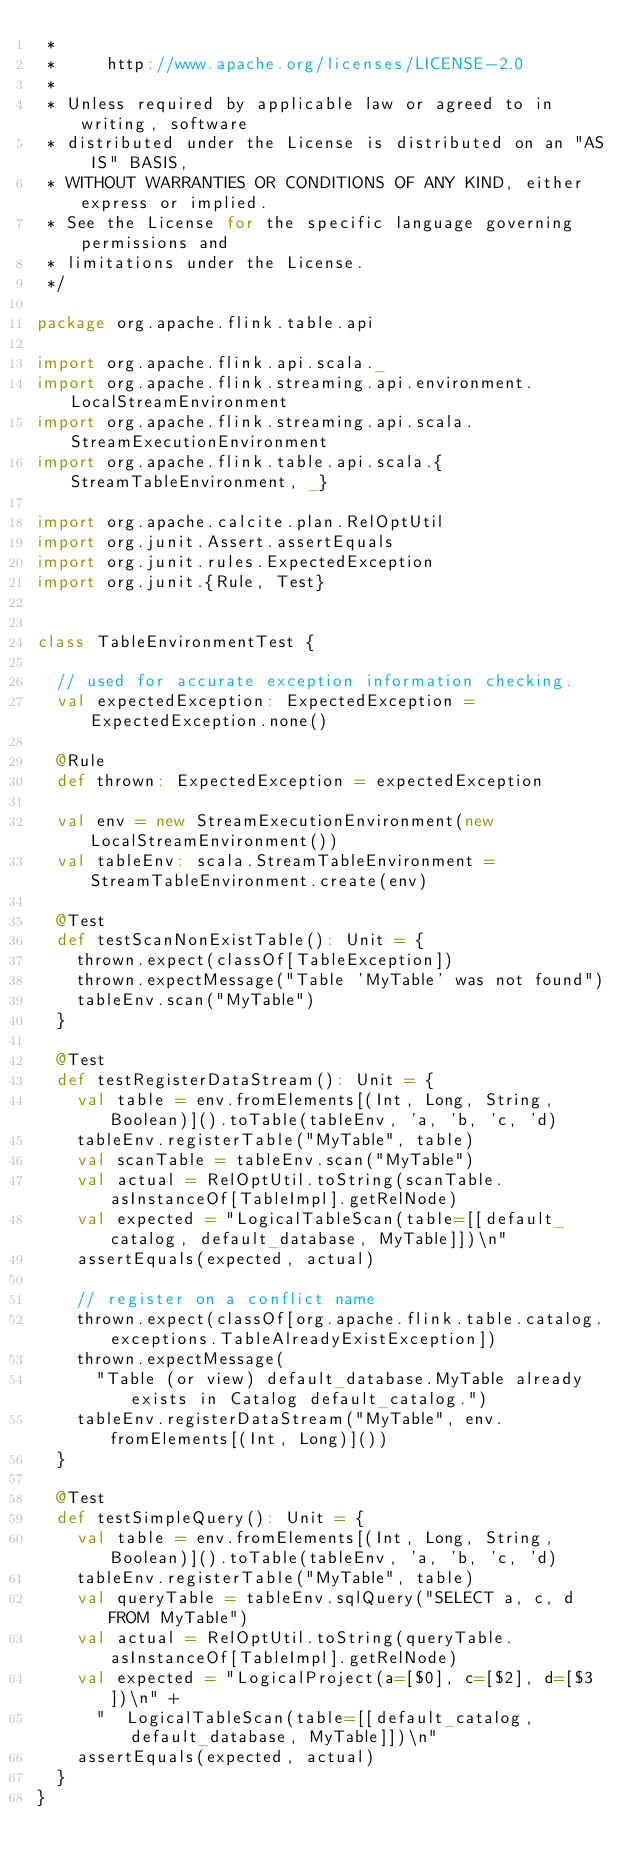<code> <loc_0><loc_0><loc_500><loc_500><_Scala_> *
 *     http://www.apache.org/licenses/LICENSE-2.0
 *
 * Unless required by applicable law or agreed to in writing, software
 * distributed under the License is distributed on an "AS IS" BASIS,
 * WITHOUT WARRANTIES OR CONDITIONS OF ANY KIND, either express or implied.
 * See the License for the specific language governing permissions and
 * limitations under the License.
 */

package org.apache.flink.table.api

import org.apache.flink.api.scala._
import org.apache.flink.streaming.api.environment.LocalStreamEnvironment
import org.apache.flink.streaming.api.scala.StreamExecutionEnvironment
import org.apache.flink.table.api.scala.{StreamTableEnvironment, _}

import org.apache.calcite.plan.RelOptUtil
import org.junit.Assert.assertEquals
import org.junit.rules.ExpectedException
import org.junit.{Rule, Test}


class TableEnvironmentTest {

  // used for accurate exception information checking.
  val expectedException: ExpectedException = ExpectedException.none()

  @Rule
  def thrown: ExpectedException = expectedException

  val env = new StreamExecutionEnvironment(new LocalStreamEnvironment())
  val tableEnv: scala.StreamTableEnvironment = StreamTableEnvironment.create(env)

  @Test
  def testScanNonExistTable(): Unit = {
    thrown.expect(classOf[TableException])
    thrown.expectMessage("Table 'MyTable' was not found")
    tableEnv.scan("MyTable")
  }

  @Test
  def testRegisterDataStream(): Unit = {
    val table = env.fromElements[(Int, Long, String, Boolean)]().toTable(tableEnv, 'a, 'b, 'c, 'd)
    tableEnv.registerTable("MyTable", table)
    val scanTable = tableEnv.scan("MyTable")
    val actual = RelOptUtil.toString(scanTable.asInstanceOf[TableImpl].getRelNode)
    val expected = "LogicalTableScan(table=[[default_catalog, default_database, MyTable]])\n"
    assertEquals(expected, actual)

    // register on a conflict name
    thrown.expect(classOf[org.apache.flink.table.catalog.exceptions.TableAlreadyExistException])
    thrown.expectMessage(
      "Table (or view) default_database.MyTable already exists in Catalog default_catalog.")
    tableEnv.registerDataStream("MyTable", env.fromElements[(Int, Long)]())
  }

  @Test
  def testSimpleQuery(): Unit = {
    val table = env.fromElements[(Int, Long, String, Boolean)]().toTable(tableEnv, 'a, 'b, 'c, 'd)
    tableEnv.registerTable("MyTable", table)
    val queryTable = tableEnv.sqlQuery("SELECT a, c, d FROM MyTable")
    val actual = RelOptUtil.toString(queryTable.asInstanceOf[TableImpl].getRelNode)
    val expected = "LogicalProject(a=[$0], c=[$2], d=[$3])\n" +
      "  LogicalTableScan(table=[[default_catalog, default_database, MyTable]])\n"
    assertEquals(expected, actual)
  }
}
</code> 